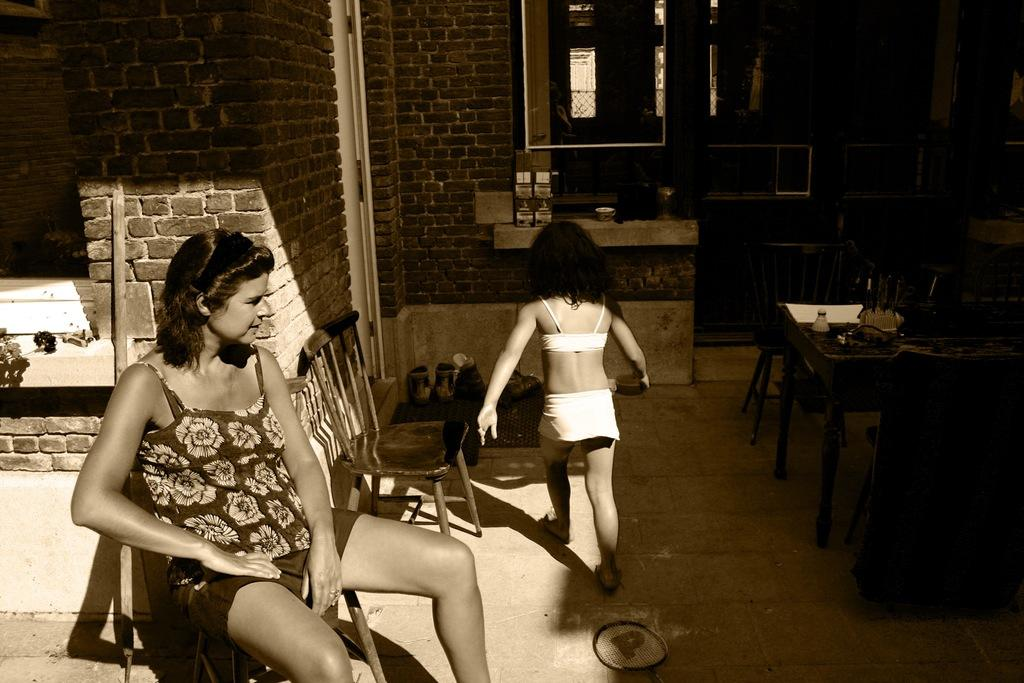What type of wall can be seen in the background of the image? There is a wall with bricks in the background. What type of furniture is present in the image? There are tables and chairs in the image. What is the girl doing in the image? The girl is walking on the floor. What is the woman doing in the image? The woman is sitting on a chair. What type of sense can be seen in the image? There is no sense present in the image; it features a wall with bricks, tables, chairs, a girl walking, and a woman sitting. What type of flesh can be seen in the image? There is no flesh visible in the image; it features a wall with bricks, tables, chairs, a girl walking, and a woman sitting. 